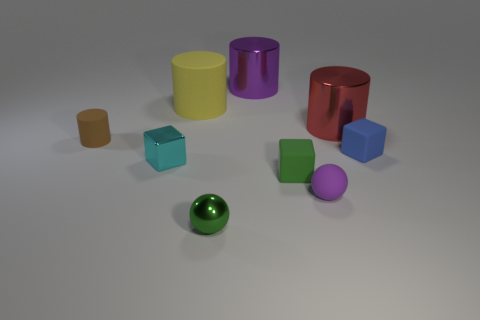Are there any patterns or relationships between the colors and shapes of the objects? Yes, there seems to be a pattern where each geometric shape is associated with a different color. For example, the cubes are blue and teal, the cylinders are yellow and purple, and the spheres are green and purple. This color-coding could be a deliberate choice to help in distinguishing between the shapes or to create an aesthetically pleasing arrangement. 